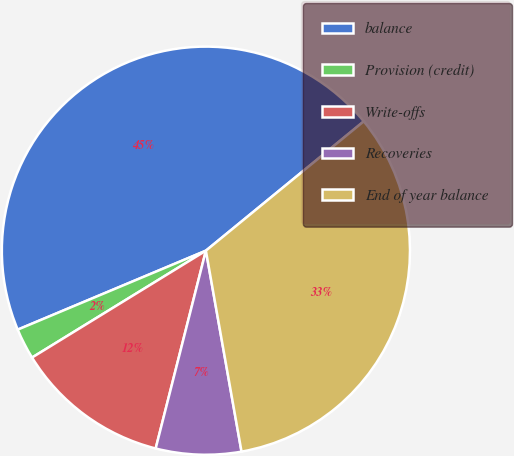Convert chart to OTSL. <chart><loc_0><loc_0><loc_500><loc_500><pie_chart><fcel>balance<fcel>Provision (credit)<fcel>Write-offs<fcel>Recoveries<fcel>End of year balance<nl><fcel>45.4%<fcel>2.45%<fcel>12.27%<fcel>6.75%<fcel>33.13%<nl></chart> 